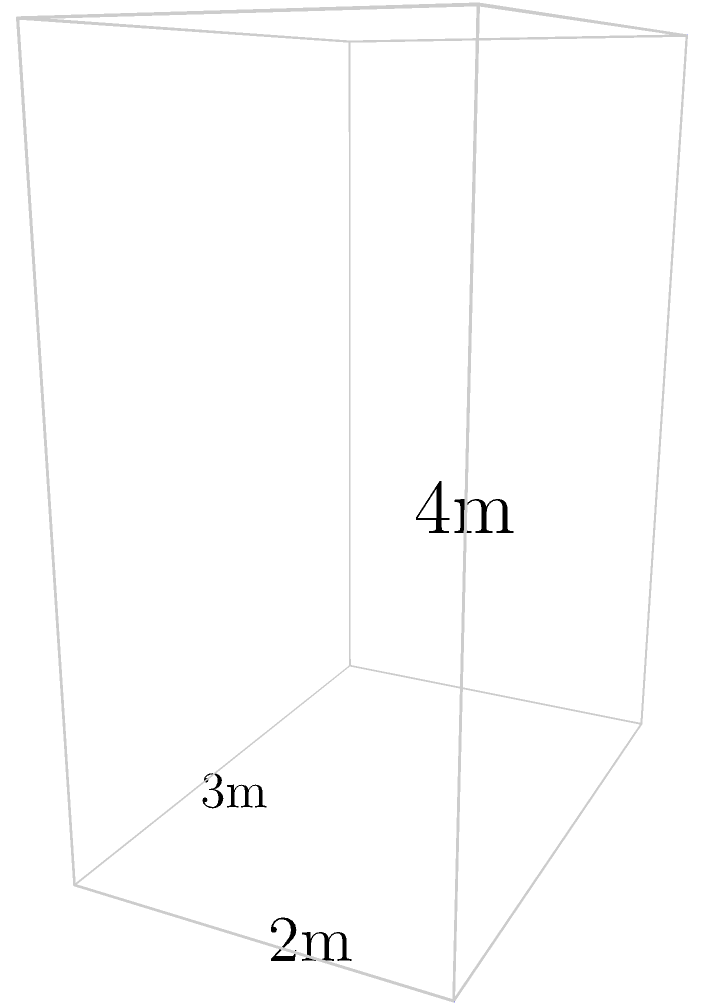In the soccer team's changing room, each player has a cuboid-shaped locker to store their gear. Your favorite midfielder's locker measures 3m in length, 2m in width, and 4m in height. What is the total surface area of this locker? Let's approach this step-by-step:

1) The locker is a cuboid with dimensions:
   Length (l) = 3m
   Width (w) = 2m
   Height (h) = 4m

2) The surface area of a cuboid is given by the formula:
   $$ SA = 2(lw + lh + wh) $$

3) Let's substitute our values:
   $$ SA = 2[(3 \times 2) + (3 \times 4) + (2 \times 4)] $$

4) Let's calculate each part:
   $$ SA = 2[6 + 12 + 8] $$

5) Sum inside the brackets:
   $$ SA = 2[26] $$

6) Final calculation:
   $$ SA = 52 $$

Therefore, the total surface area of the locker is 52 square meters.
Answer: 52 m² 